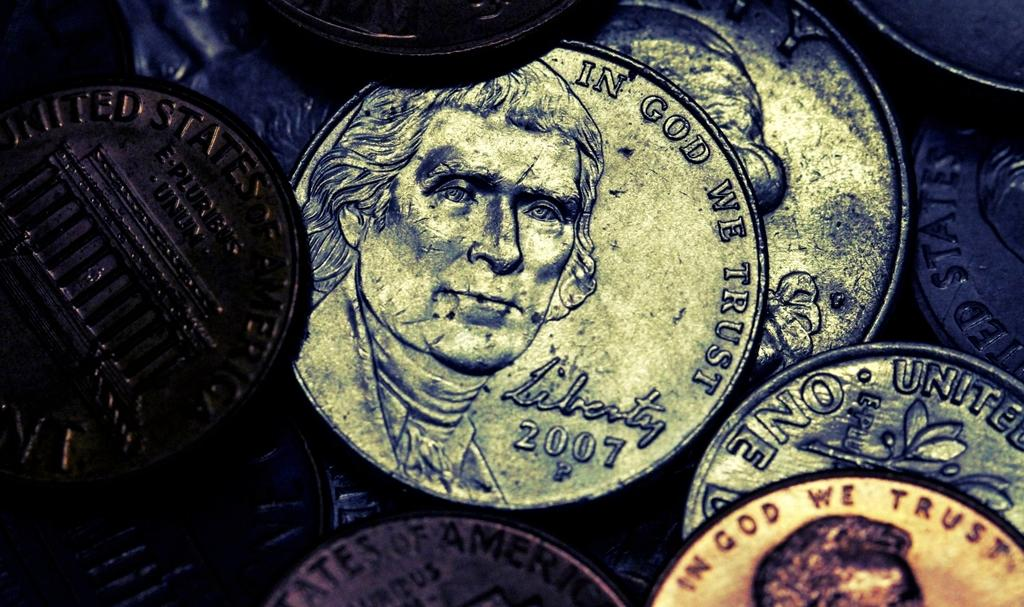<image>
Relay a brief, clear account of the picture shown. A pile of coins with In God We Trust on them. 